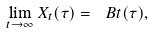Convert formula to latex. <formula><loc_0><loc_0><loc_500><loc_500>\lim _ { t \to \infty } X _ { t } ( \tau ) = \ B t ( \tau ) ,</formula> 